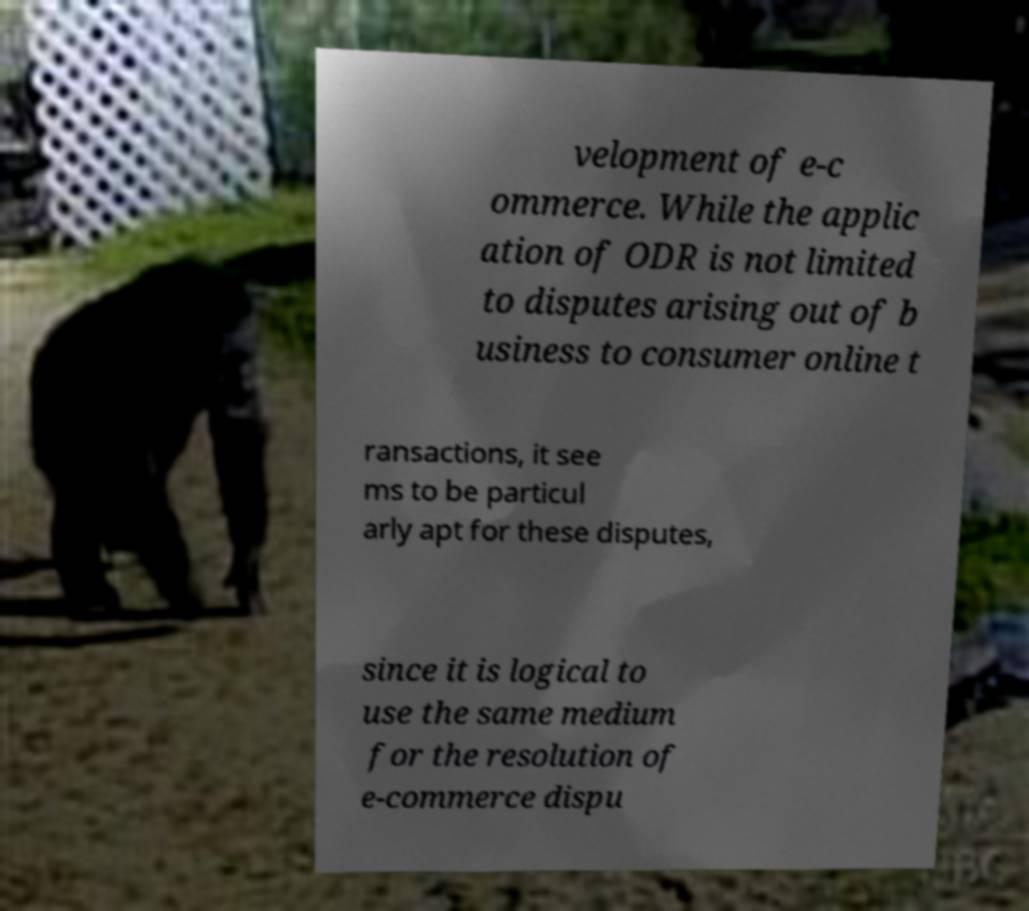I need the written content from this picture converted into text. Can you do that? velopment of e-c ommerce. While the applic ation of ODR is not limited to disputes arising out of b usiness to consumer online t ransactions, it see ms to be particul arly apt for these disputes, since it is logical to use the same medium for the resolution of e-commerce dispu 